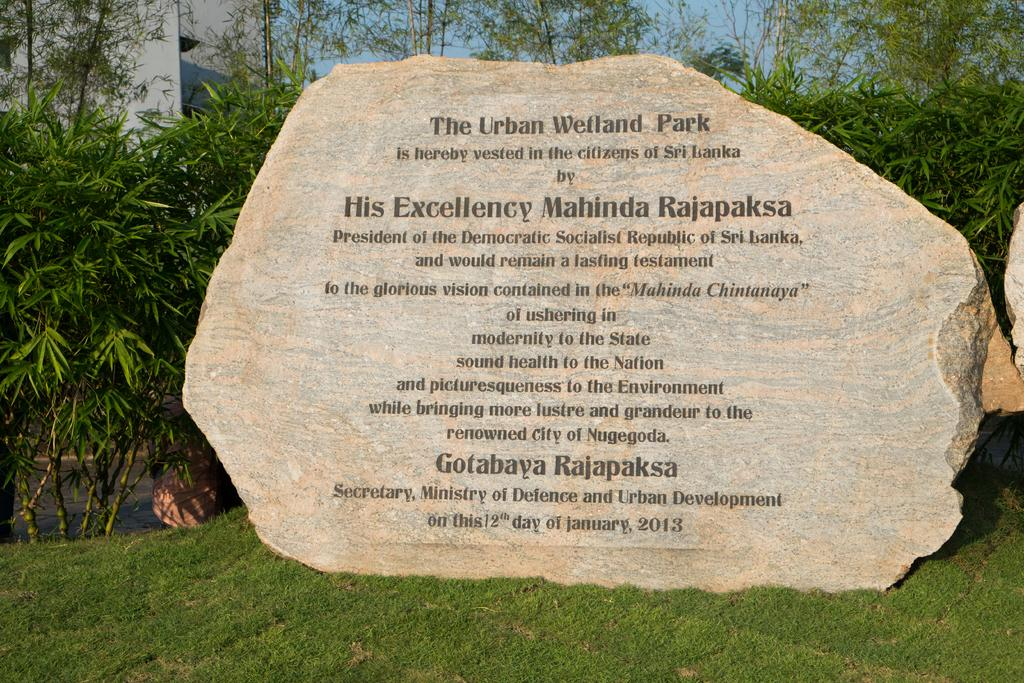What type of vegetation is present in the image? There is grass and trees in the image. What other objects can be seen in the image? There is a rock and a building in the image. Can you describe the natural elements in the image? The natural elements include grass and trees. What type of structure is visible in the image? There is a building in the image. How many nuts are growing on the stem in the image? There are no nuts or stems present in the image. What type of wish can be granted by the rock in the image? There is no mention of wishes or magical properties associated with the rock in the image. 